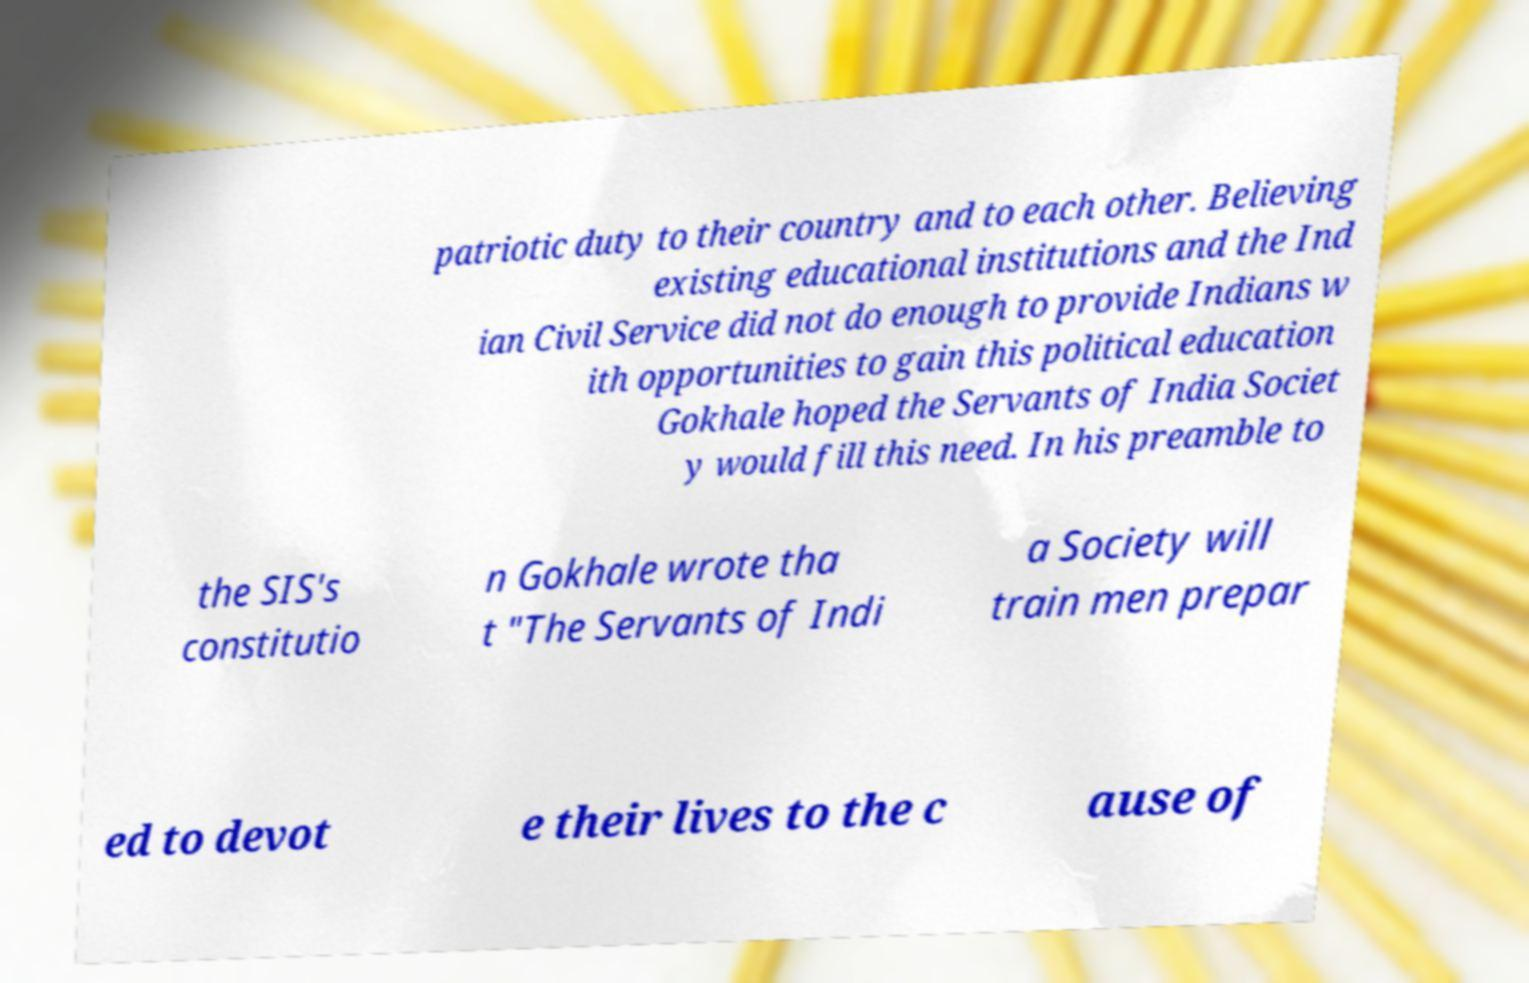Can you accurately transcribe the text from the provided image for me? patriotic duty to their country and to each other. Believing existing educational institutions and the Ind ian Civil Service did not do enough to provide Indians w ith opportunities to gain this political education Gokhale hoped the Servants of India Societ y would fill this need. In his preamble to the SIS's constitutio n Gokhale wrote tha t "The Servants of Indi a Society will train men prepar ed to devot e their lives to the c ause of 